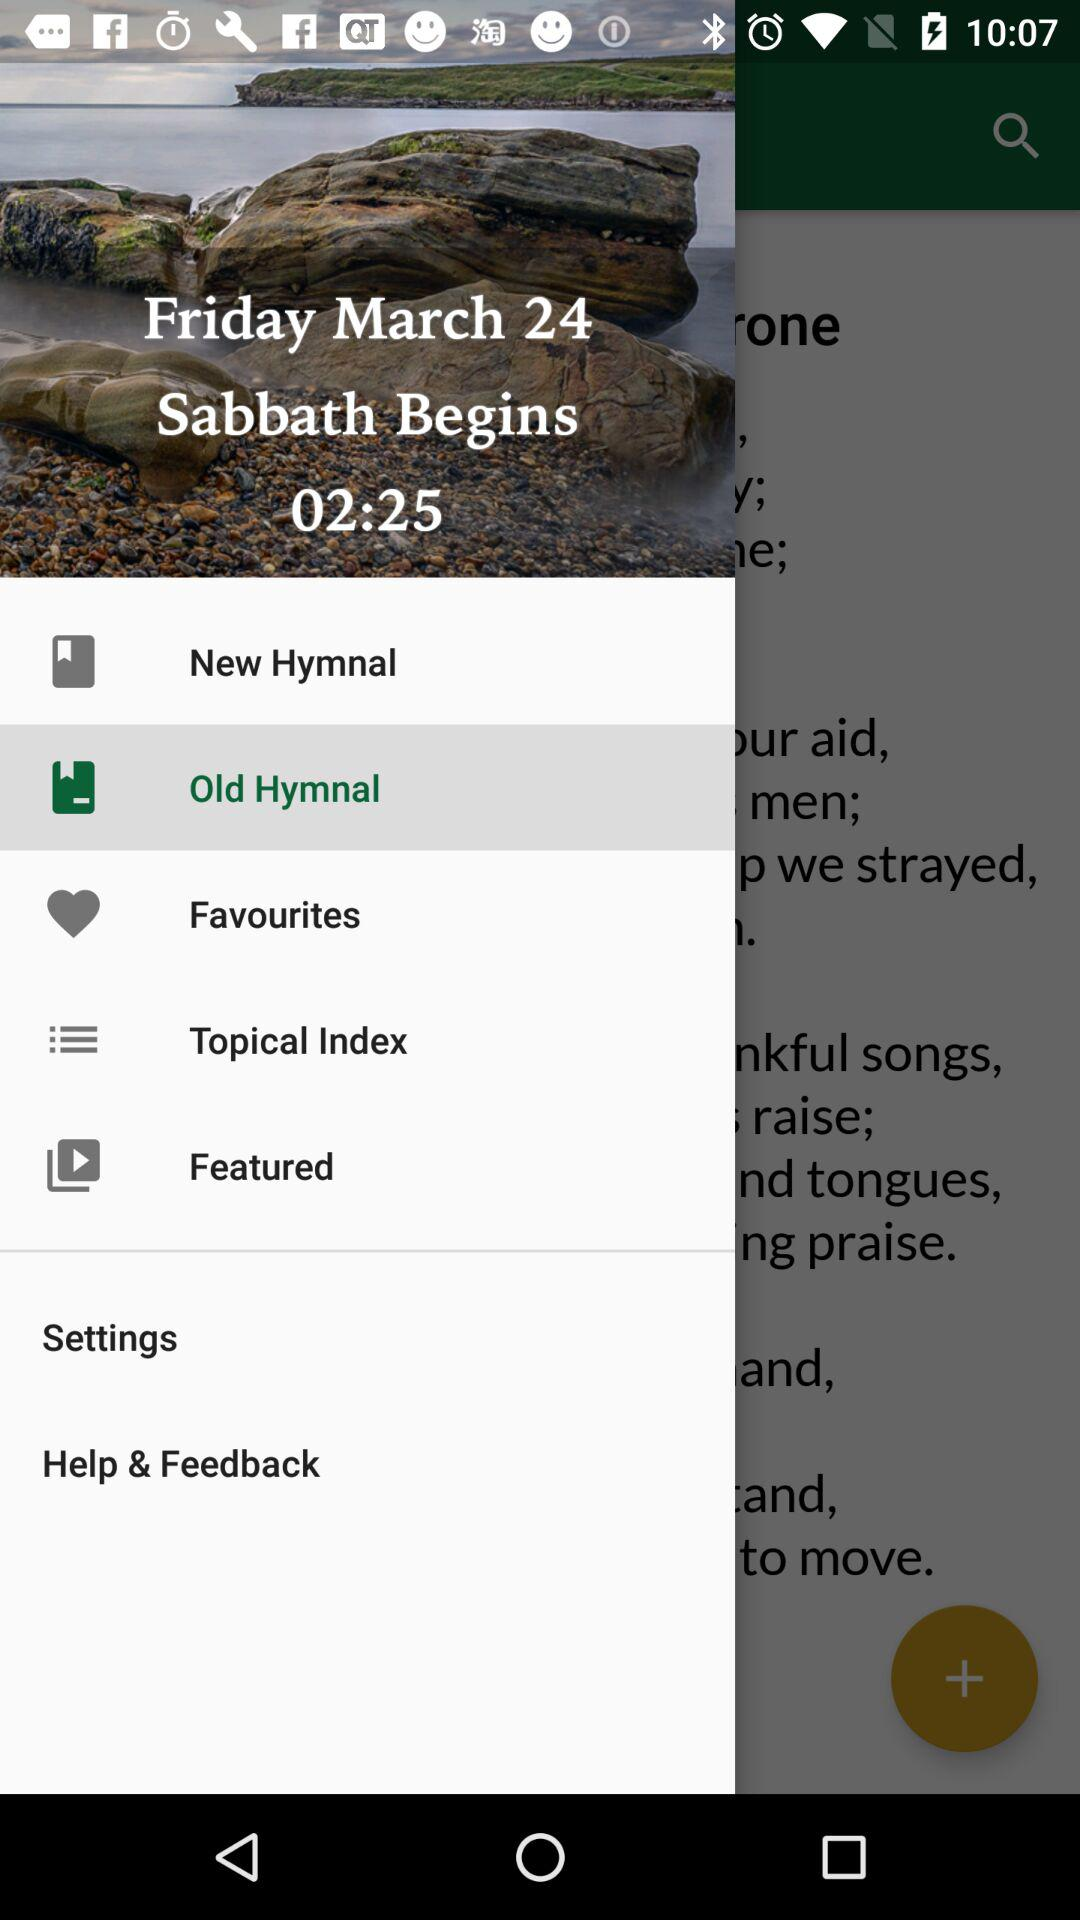On what date did the "Sabbath" begin? "Sabbath" began on Friday, March 24. 